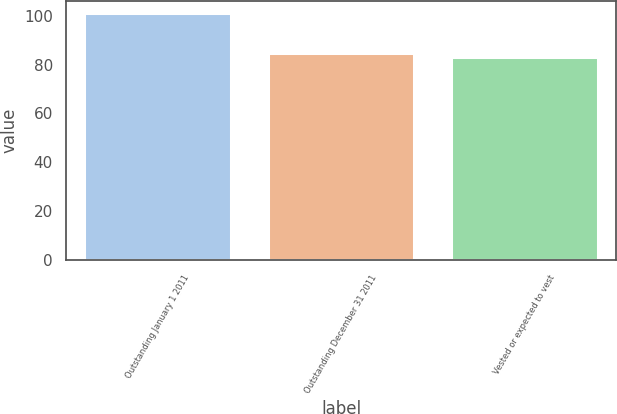Convert chart. <chart><loc_0><loc_0><loc_500><loc_500><bar_chart><fcel>Outstanding January 1 2011<fcel>Outstanding December 31 2011<fcel>Vested or expected to vest<nl><fcel>101<fcel>84.8<fcel>83<nl></chart> 